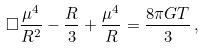<formula> <loc_0><loc_0><loc_500><loc_500>\Box \frac { \mu ^ { 4 } } { R ^ { 2 } } - \frac { R } { 3 } + \frac { \mu ^ { 4 } } { R } = \frac { 8 \pi G T } { 3 } \, ,</formula> 